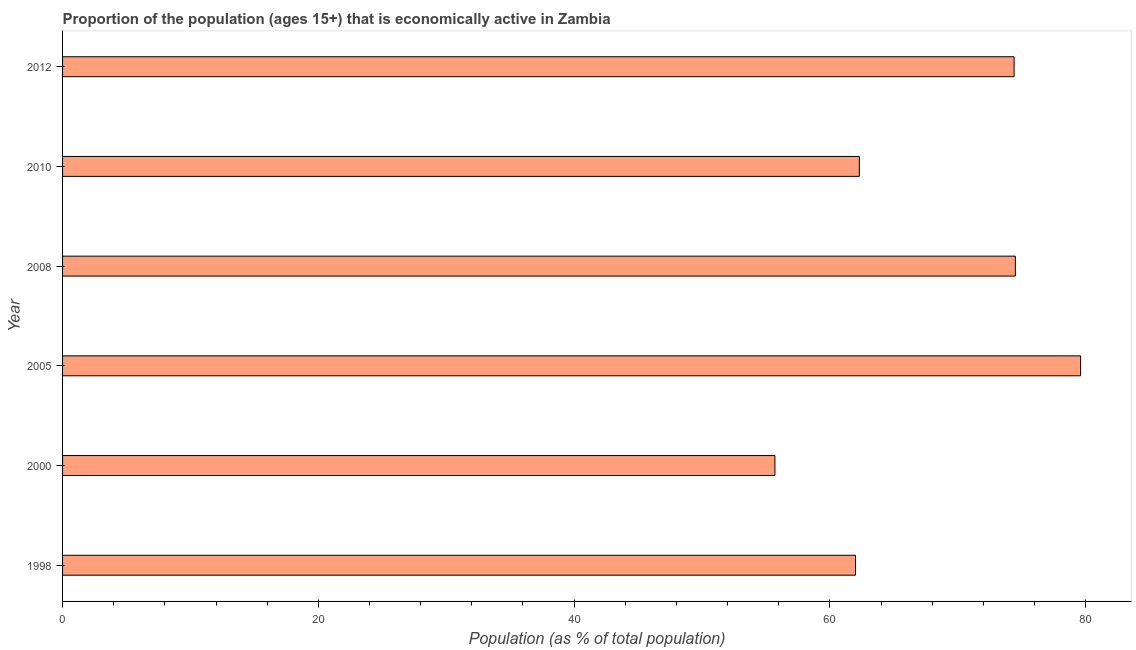Does the graph contain any zero values?
Your answer should be compact. No. Does the graph contain grids?
Keep it short and to the point. No. What is the title of the graph?
Give a very brief answer. Proportion of the population (ages 15+) that is economically active in Zambia. What is the label or title of the X-axis?
Ensure brevity in your answer.  Population (as % of total population). Across all years, what is the maximum percentage of economically active population?
Give a very brief answer. 79.6. Across all years, what is the minimum percentage of economically active population?
Keep it short and to the point. 55.7. In which year was the percentage of economically active population maximum?
Offer a very short reply. 2005. What is the sum of the percentage of economically active population?
Offer a very short reply. 408.5. What is the difference between the percentage of economically active population in 2000 and 2005?
Your answer should be very brief. -23.9. What is the average percentage of economically active population per year?
Your response must be concise. 68.08. What is the median percentage of economically active population?
Your answer should be compact. 68.35. In how many years, is the percentage of economically active population greater than 4 %?
Provide a succinct answer. 6. Do a majority of the years between 1998 and 2010 (inclusive) have percentage of economically active population greater than 68 %?
Offer a very short reply. No. What is the ratio of the percentage of economically active population in 1998 to that in 2005?
Provide a succinct answer. 0.78. Is the percentage of economically active population in 1998 less than that in 2010?
Provide a succinct answer. Yes. Is the difference between the percentage of economically active population in 1998 and 2005 greater than the difference between any two years?
Ensure brevity in your answer.  No. Is the sum of the percentage of economically active population in 2008 and 2010 greater than the maximum percentage of economically active population across all years?
Keep it short and to the point. Yes. What is the difference between the highest and the lowest percentage of economically active population?
Offer a terse response. 23.9. In how many years, is the percentage of economically active population greater than the average percentage of economically active population taken over all years?
Provide a short and direct response. 3. Are all the bars in the graph horizontal?
Offer a very short reply. Yes. How many years are there in the graph?
Give a very brief answer. 6. What is the difference between two consecutive major ticks on the X-axis?
Keep it short and to the point. 20. Are the values on the major ticks of X-axis written in scientific E-notation?
Offer a very short reply. No. What is the Population (as % of total population) of 2000?
Provide a succinct answer. 55.7. What is the Population (as % of total population) in 2005?
Make the answer very short. 79.6. What is the Population (as % of total population) in 2008?
Your answer should be compact. 74.5. What is the Population (as % of total population) in 2010?
Keep it short and to the point. 62.3. What is the Population (as % of total population) in 2012?
Keep it short and to the point. 74.4. What is the difference between the Population (as % of total population) in 1998 and 2000?
Your response must be concise. 6.3. What is the difference between the Population (as % of total population) in 1998 and 2005?
Provide a short and direct response. -17.6. What is the difference between the Population (as % of total population) in 1998 and 2010?
Keep it short and to the point. -0.3. What is the difference between the Population (as % of total population) in 2000 and 2005?
Offer a terse response. -23.9. What is the difference between the Population (as % of total population) in 2000 and 2008?
Your answer should be compact. -18.8. What is the difference between the Population (as % of total population) in 2000 and 2012?
Offer a very short reply. -18.7. What is the difference between the Population (as % of total population) in 2005 and 2010?
Your answer should be compact. 17.3. What is the difference between the Population (as % of total population) in 2008 and 2010?
Provide a short and direct response. 12.2. What is the difference between the Population (as % of total population) in 2008 and 2012?
Give a very brief answer. 0.1. What is the difference between the Population (as % of total population) in 2010 and 2012?
Provide a succinct answer. -12.1. What is the ratio of the Population (as % of total population) in 1998 to that in 2000?
Ensure brevity in your answer.  1.11. What is the ratio of the Population (as % of total population) in 1998 to that in 2005?
Make the answer very short. 0.78. What is the ratio of the Population (as % of total population) in 1998 to that in 2008?
Your answer should be very brief. 0.83. What is the ratio of the Population (as % of total population) in 1998 to that in 2012?
Provide a succinct answer. 0.83. What is the ratio of the Population (as % of total population) in 2000 to that in 2008?
Your response must be concise. 0.75. What is the ratio of the Population (as % of total population) in 2000 to that in 2010?
Offer a very short reply. 0.89. What is the ratio of the Population (as % of total population) in 2000 to that in 2012?
Keep it short and to the point. 0.75. What is the ratio of the Population (as % of total population) in 2005 to that in 2008?
Provide a short and direct response. 1.07. What is the ratio of the Population (as % of total population) in 2005 to that in 2010?
Make the answer very short. 1.28. What is the ratio of the Population (as % of total population) in 2005 to that in 2012?
Offer a terse response. 1.07. What is the ratio of the Population (as % of total population) in 2008 to that in 2010?
Provide a short and direct response. 1.2. What is the ratio of the Population (as % of total population) in 2008 to that in 2012?
Provide a short and direct response. 1. What is the ratio of the Population (as % of total population) in 2010 to that in 2012?
Provide a succinct answer. 0.84. 